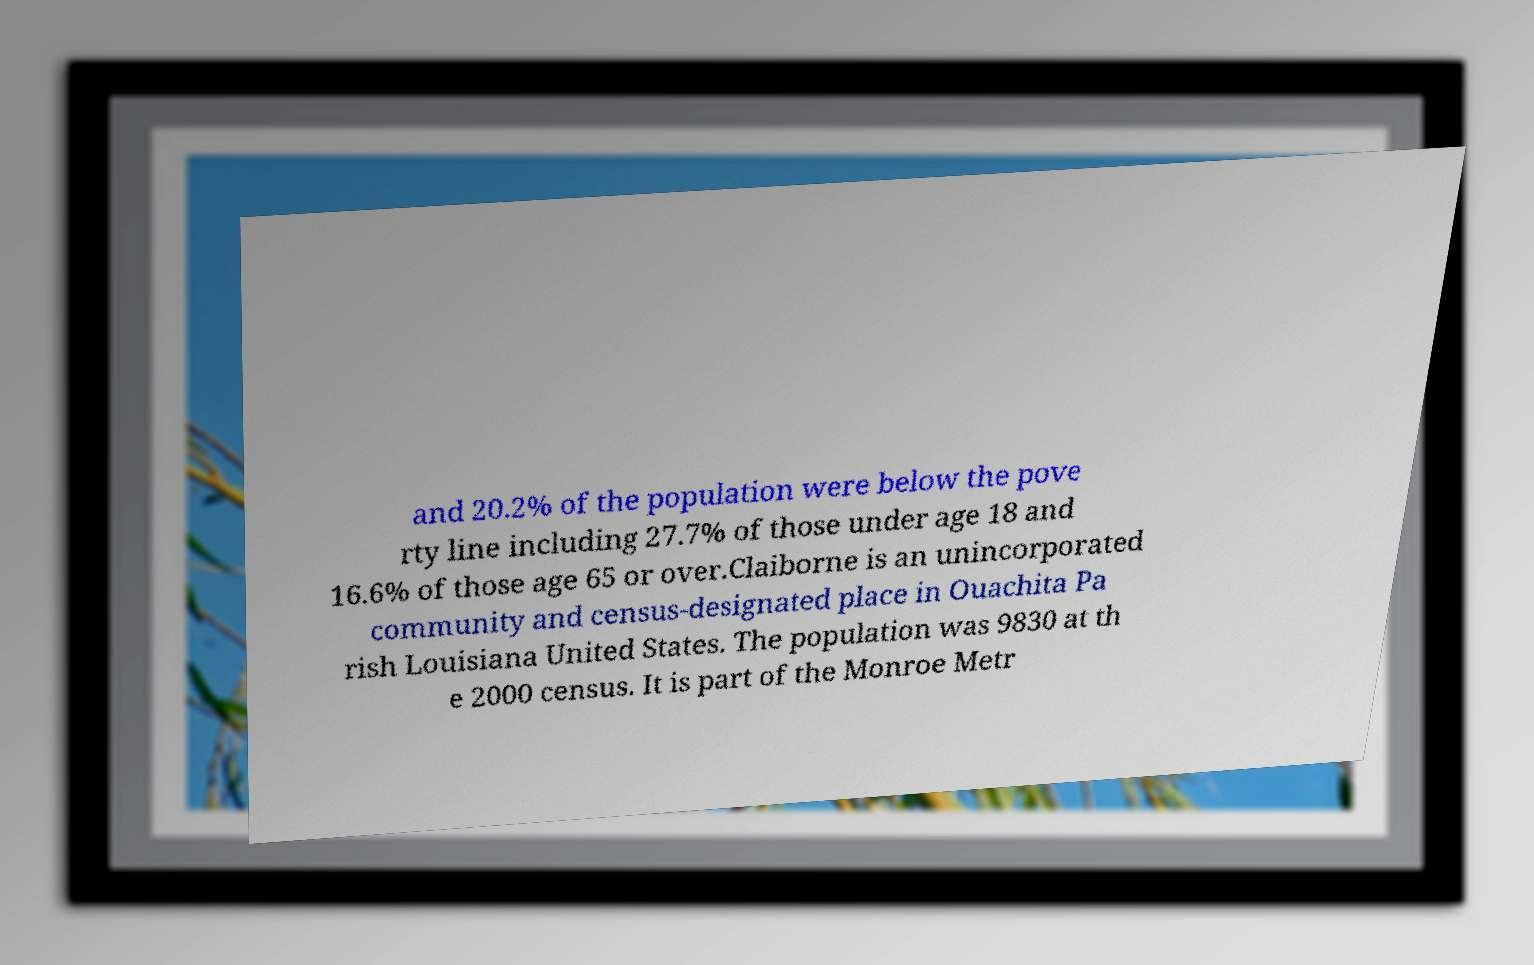I need the written content from this picture converted into text. Can you do that? and 20.2% of the population were below the pove rty line including 27.7% of those under age 18 and 16.6% of those age 65 or over.Claiborne is an unincorporated community and census-designated place in Ouachita Pa rish Louisiana United States. The population was 9830 at th e 2000 census. It is part of the Monroe Metr 